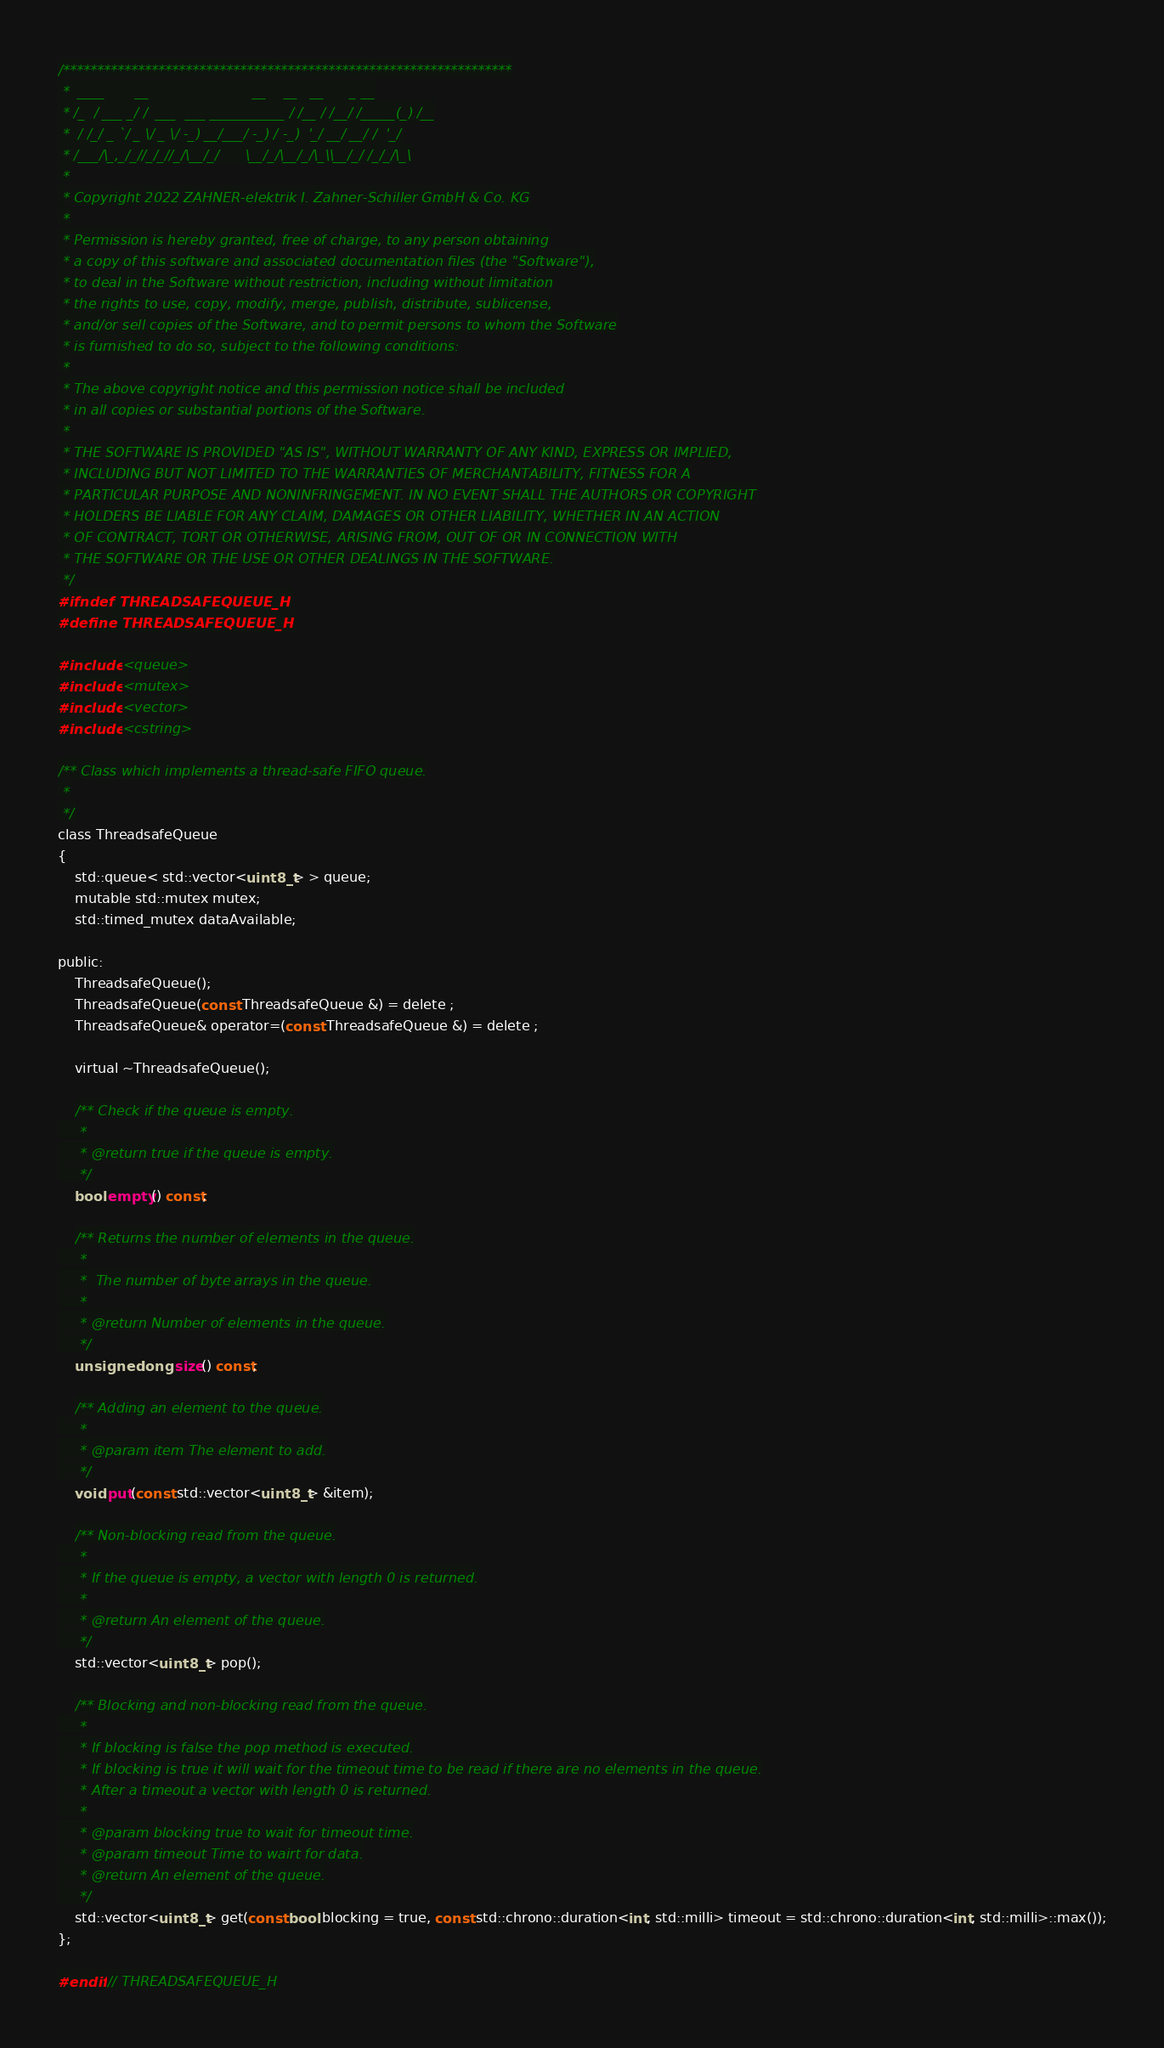<code> <loc_0><loc_0><loc_500><loc_500><_C_>/******************************************************************
 *  ____       __                        __    __   __      _ __
 * /_  / ___ _/ /  ___  ___ ___________ / /__ / /__/ /_____(_) /__
 *  / /_/ _ `/ _ \/ _ \/ -_) __/___/ -_) / -_)  '_/ __/ __/ /  '_/
 * /___/\_,_/_//_/_//_/\__/_/      \__/_/\__/_/\_\\__/_/ /_/_/\_\
 *
 * Copyright 2022 ZAHNER-elektrik I. Zahner-Schiller GmbH & Co. KG
 *
 * Permission is hereby granted, free of charge, to any person obtaining
 * a copy of this software and associated documentation files (the "Software"),
 * to deal in the Software without restriction, including without limitation
 * the rights to use, copy, modify, merge, publish, distribute, sublicense,
 * and/or sell copies of the Software, and to permit persons to whom the Software
 * is furnished to do so, subject to the following conditions:
 *
 * The above copyright notice and this permission notice shall be included
 * in all copies or substantial portions of the Software.
 *
 * THE SOFTWARE IS PROVIDED "AS IS", WITHOUT WARRANTY OF ANY KIND, EXPRESS OR IMPLIED,
 * INCLUDING BUT NOT LIMITED TO THE WARRANTIES OF MERCHANTABILITY, FITNESS FOR A
 * PARTICULAR PURPOSE AND NONINFRINGEMENT. IN NO EVENT SHALL THE AUTHORS OR COPYRIGHT
 * HOLDERS BE LIABLE FOR ANY CLAIM, DAMAGES OR OTHER LIABILITY, WHETHER IN AN ACTION
 * OF CONTRACT, TORT OR OTHERWISE, ARISING FROM, OUT OF OR IN CONNECTION WITH
 * THE SOFTWARE OR THE USE OR OTHER DEALINGS IN THE SOFTWARE.
 */
#ifndef THREADSAFEQUEUE_H
#define THREADSAFEQUEUE_H

#include <queue>
#include <mutex>
#include <vector>
#include <cstring>

/** Class which implements a thread-safe FIFO queue.
 *
 */
class ThreadsafeQueue
{
    std::queue< std::vector<uint8_t> > queue;
    mutable std::mutex mutex;
    std::timed_mutex dataAvailable;

public:
    ThreadsafeQueue();
    ThreadsafeQueue(const ThreadsafeQueue &) = delete ;
    ThreadsafeQueue& operator=(const ThreadsafeQueue &) = delete ;

    virtual ~ThreadsafeQueue();

    /** Check if the queue is empty.
     *
     * @return true if the queue is empty.
     */
    bool empty() const;

    /** Returns the number of elements in the queue.
     *
     *  The number of byte arrays in the queue.
     *
     * @return Number of elements in the queue.
     */
    unsigned long size() const;

    /** Adding an element to the queue.
     *
     * @param item The element to add.
     */
    void put(const std::vector<uint8_t> &item);

    /** Non-blocking read from the queue.
     *
     * If the queue is empty, a vector with length 0 is returned.
     *
     * @return An element of the queue.
     */
    std::vector<uint8_t> pop();

    /** Blocking and non-blocking read from the queue.
     *
     * If blocking is false the pop method is executed.
     * If blocking is true it will wait for the timeout time to be read if there are no elements in the queue.
     * After a timeout a vector with length 0 is returned.
     *
     * @param blocking true to wait for timeout time.
     * @param timeout Time to wairt for data.
     * @return An element of the queue.
     */
    std::vector<uint8_t> get(const bool blocking = true, const std::chrono::duration<int, std::milli> timeout = std::chrono::duration<int, std::milli>::max());
};

#endif // THREADSAFEQUEUE_H
</code> 